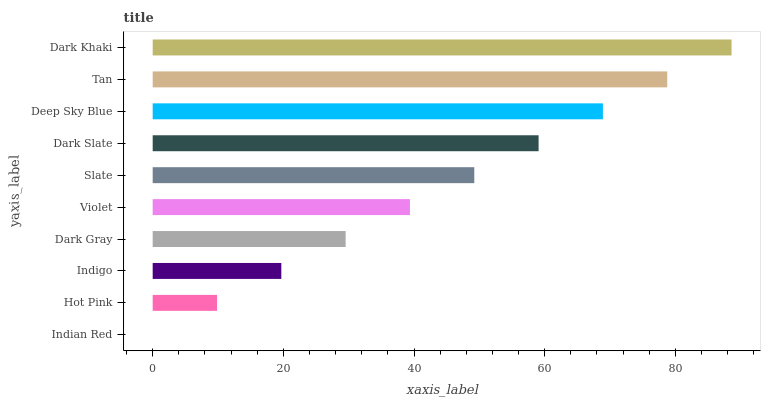Is Indian Red the minimum?
Answer yes or no. Yes. Is Dark Khaki the maximum?
Answer yes or no. Yes. Is Hot Pink the minimum?
Answer yes or no. No. Is Hot Pink the maximum?
Answer yes or no. No. Is Hot Pink greater than Indian Red?
Answer yes or no. Yes. Is Indian Red less than Hot Pink?
Answer yes or no. Yes. Is Indian Red greater than Hot Pink?
Answer yes or no. No. Is Hot Pink less than Indian Red?
Answer yes or no. No. Is Slate the high median?
Answer yes or no. Yes. Is Violet the low median?
Answer yes or no. Yes. Is Tan the high median?
Answer yes or no. No. Is Dark Gray the low median?
Answer yes or no. No. 